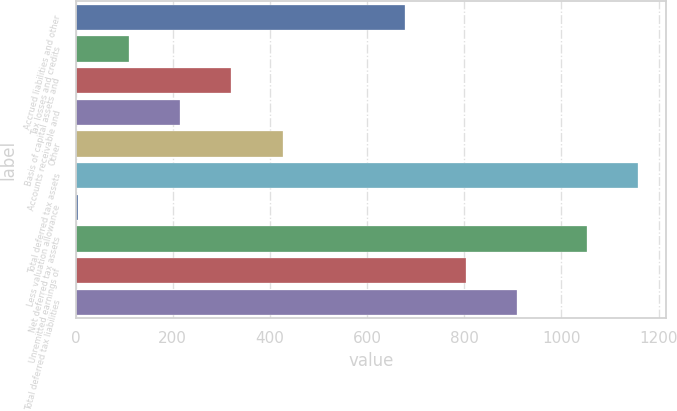Convert chart. <chart><loc_0><loc_0><loc_500><loc_500><bar_chart><fcel>Accrued liabilities and other<fcel>Tax losses and credits<fcel>Basis of capital assets and<fcel>Accounts receivable and<fcel>Other<fcel>Total deferred tax assets<fcel>Less valuation allowance<fcel>Net deferred tax assets<fcel>Unremitted earnings of<fcel>Total deferred tax liabilities<nl><fcel>679<fcel>110.3<fcel>320.9<fcel>215.6<fcel>426.2<fcel>1158.3<fcel>5<fcel>1053<fcel>803<fcel>908.3<nl></chart> 